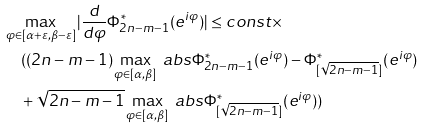Convert formula to latex. <formula><loc_0><loc_0><loc_500><loc_500>& \max _ { \varphi \in [ \alpha + \varepsilon , \beta - \varepsilon ] } | \frac { d } { d \varphi } \Phi _ { 2 n - m - 1 } ^ { * } ( e ^ { i \varphi } ) | \leq c o n s t \times \\ & \quad ( ( 2 n - m - 1 ) \max _ { \varphi \in [ \alpha , \beta ] } \ a b s { \Phi _ { 2 n - m - 1 } ^ { * } ( e ^ { i \varphi } ) - \Phi _ { [ \sqrt { 2 n - m - 1 } ] } ^ { * } ( e ^ { i \varphi } ) } \\ & \quad + \sqrt { 2 n - m - 1 } \max _ { \varphi \in [ \alpha , \beta ] } \ a b s { \Phi _ { [ \sqrt { 2 n - m - 1 } ] } ^ { * } ( e ^ { i \varphi } ) } )</formula> 